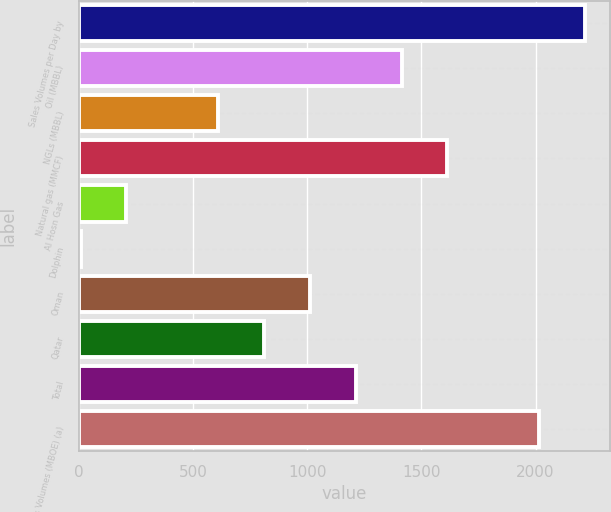<chart> <loc_0><loc_0><loc_500><loc_500><bar_chart><fcel>Sales Volumes per Day by<fcel>Oil (MBBL)<fcel>NGLs (MBBL)<fcel>Natural gas (MMCF)<fcel>Al Hosn Gas<fcel>Dolphin<fcel>Oman<fcel>Qatar<fcel>Total<fcel>Total Sales Volumes (MBOE) (a)<nl><fcel>2216.9<fcel>1413.3<fcel>609.7<fcel>1614.2<fcel>207.9<fcel>7<fcel>1011.5<fcel>810.6<fcel>1212.4<fcel>2016<nl></chart> 